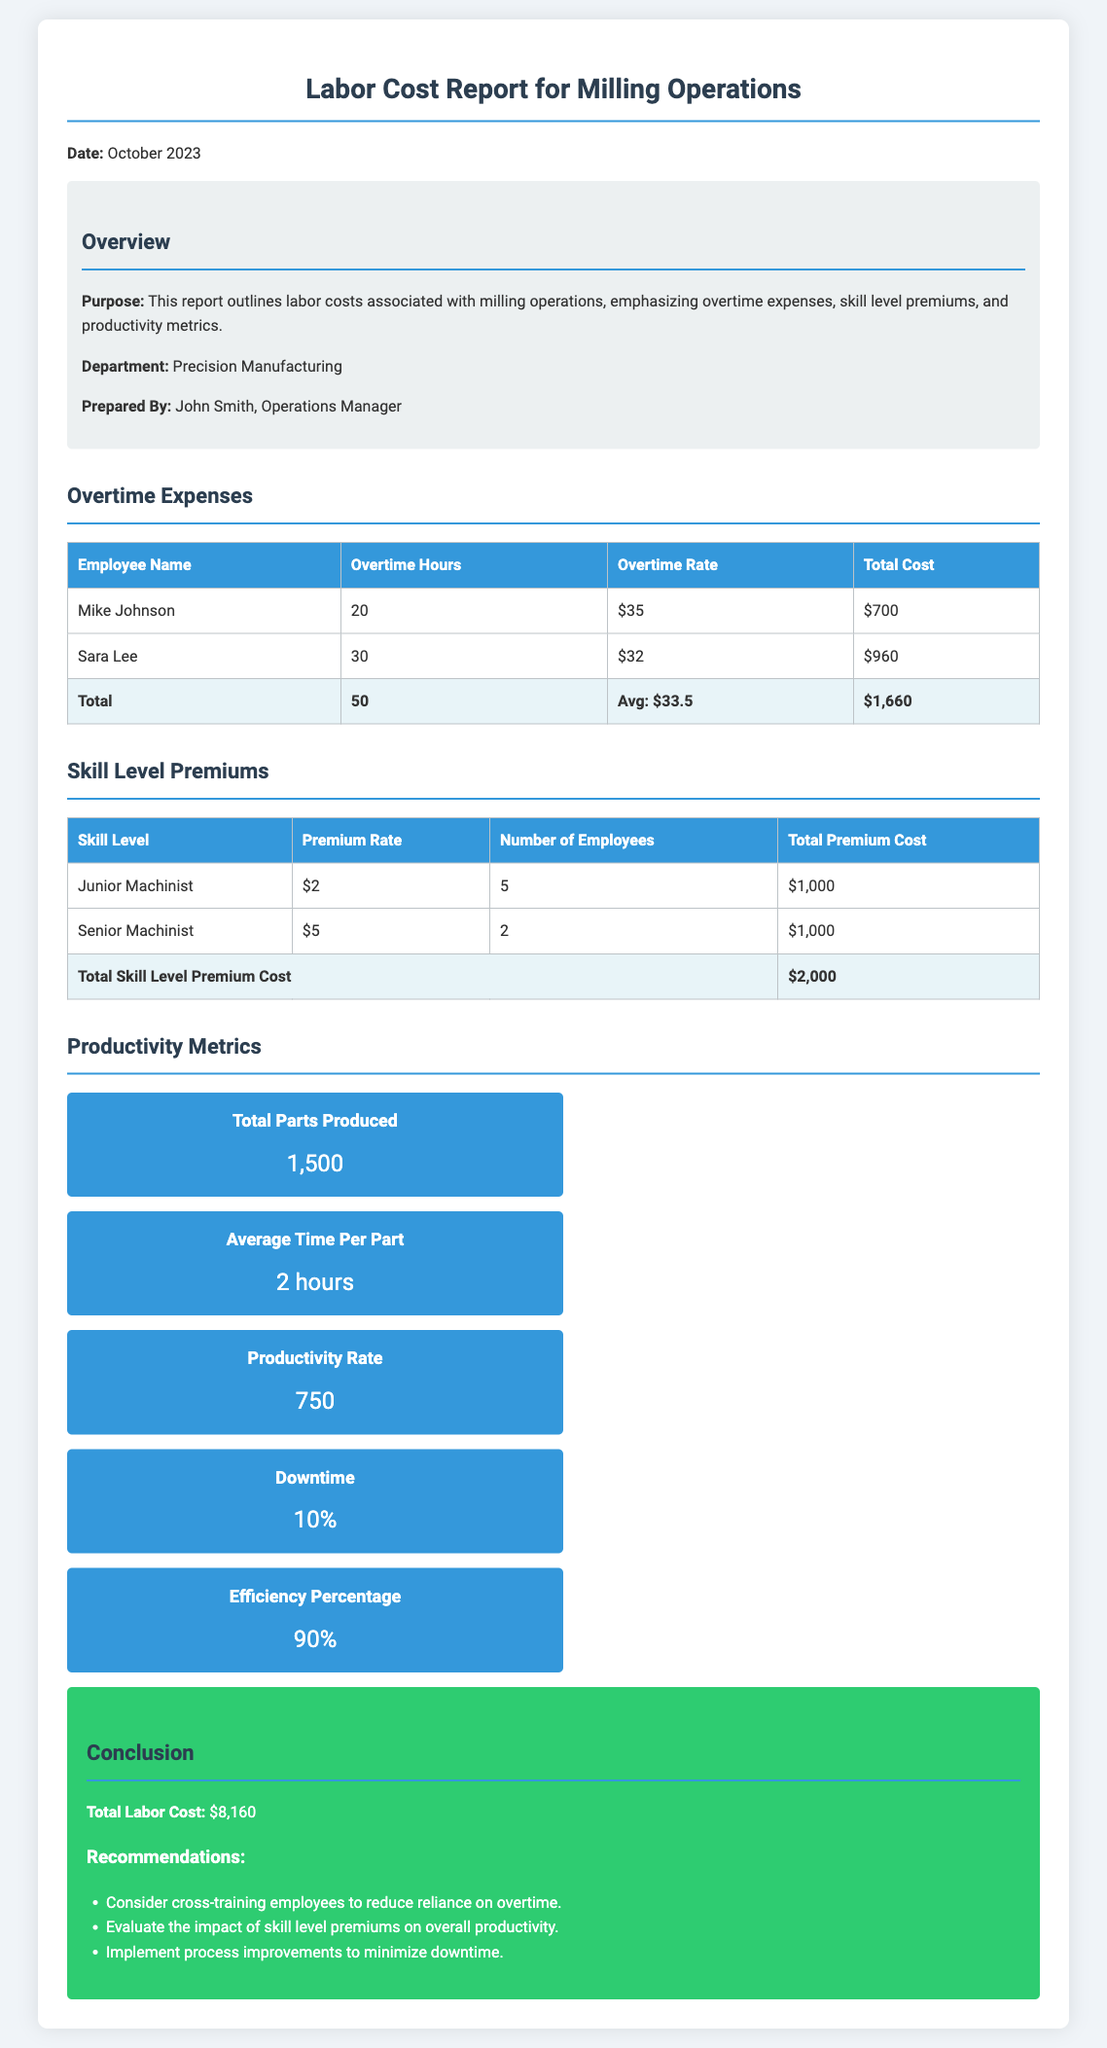What is the total overtime cost? The total overtime cost is the sum of individual costs for employees listed in the report, which is $700 + $960 = $1,660.
Answer: $1,660 How many hours of overtime did Sara Lee log? The document states that Sara Lee worked 30 overtime hours.
Answer: 30 What is the average overtime rate? The average overtime rate is calculated based on the rates provided, which is $(35 + 32) / 2 = $33.5.
Answer: $33.5 What is the total skill level premium cost? The document reports the total cost for skill level premiums as $1,000 + $1,000 = $2,000.
Answer: $2,000 How many total parts were produced? The document states that a total of 1,500 parts were produced during the reporting period.
Answer: 1,500 What is the efficiency percentage reported? The report indicates the efficiency percentage is 90%.
Answer: 90% What is the average time per part produced? The report mentions that the average time per part is 2 hours.
Answer: 2 hours Who prepared the labor cost report? The document indicates that John Smith, Operations Manager, prepared the report.
Answer: John Smith What recommendations are made regarding employee training? The document recommends considering cross-training employees to reduce reliance on overtime.
Answer: Cross-training employees What is the total labor cost outlined in the report? The total labor cost is mentioned at the conclusion of the report, which is $8,160.
Answer: $8,160 